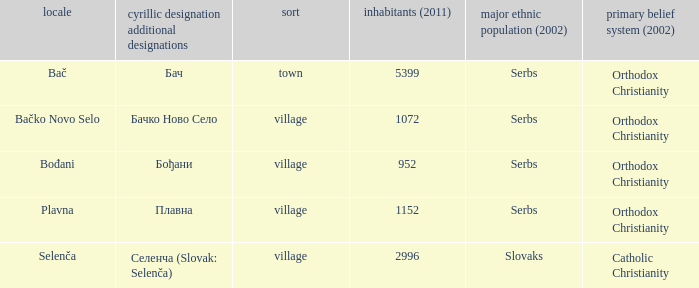What is the ethnic majority in the only town? Serbs. Could you parse the entire table? {'header': ['locale', 'cyrillic designation additional designations', 'sort', 'inhabitants (2011)', 'major ethnic population (2002)', 'primary belief system (2002)'], 'rows': [['Bač', 'Бач', 'town', '5399', 'Serbs', 'Orthodox Christianity'], ['Bačko Novo Selo', 'Бачко Ново Село', 'village', '1072', 'Serbs', 'Orthodox Christianity'], ['Bođani', 'Бођани', 'village', '952', 'Serbs', 'Orthodox Christianity'], ['Plavna', 'Плавна', 'village', '1152', 'Serbs', 'Orthodox Christianity'], ['Selenča', 'Селенча (Slovak: Selenča)', 'village', '2996', 'Slovaks', 'Catholic Christianity']]} 